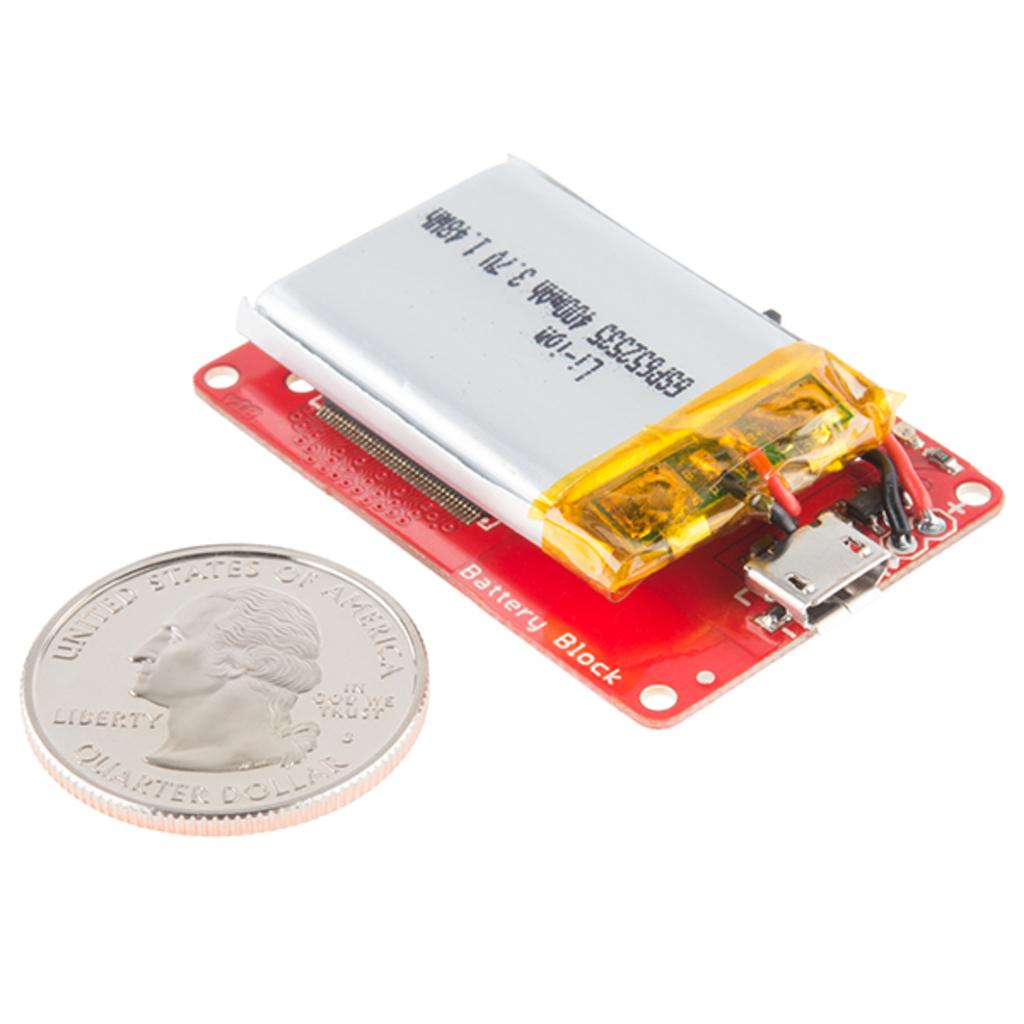<image>
Give a short and clear explanation of the subsequent image. A quarter laying beside a silver battery on a battery block 